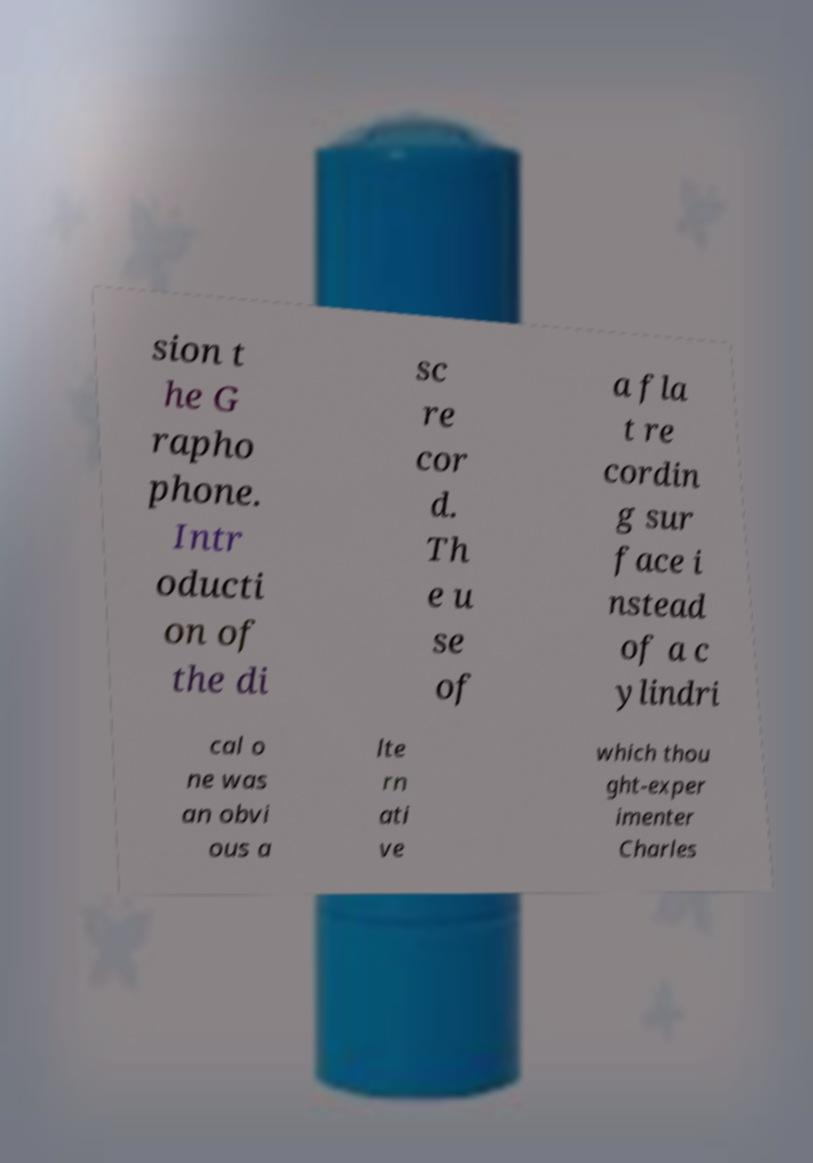What messages or text are displayed in this image? I need them in a readable, typed format. sion t he G rapho phone. Intr oducti on of the di sc re cor d. Th e u se of a fla t re cordin g sur face i nstead of a c ylindri cal o ne was an obvi ous a lte rn ati ve which thou ght-exper imenter Charles 